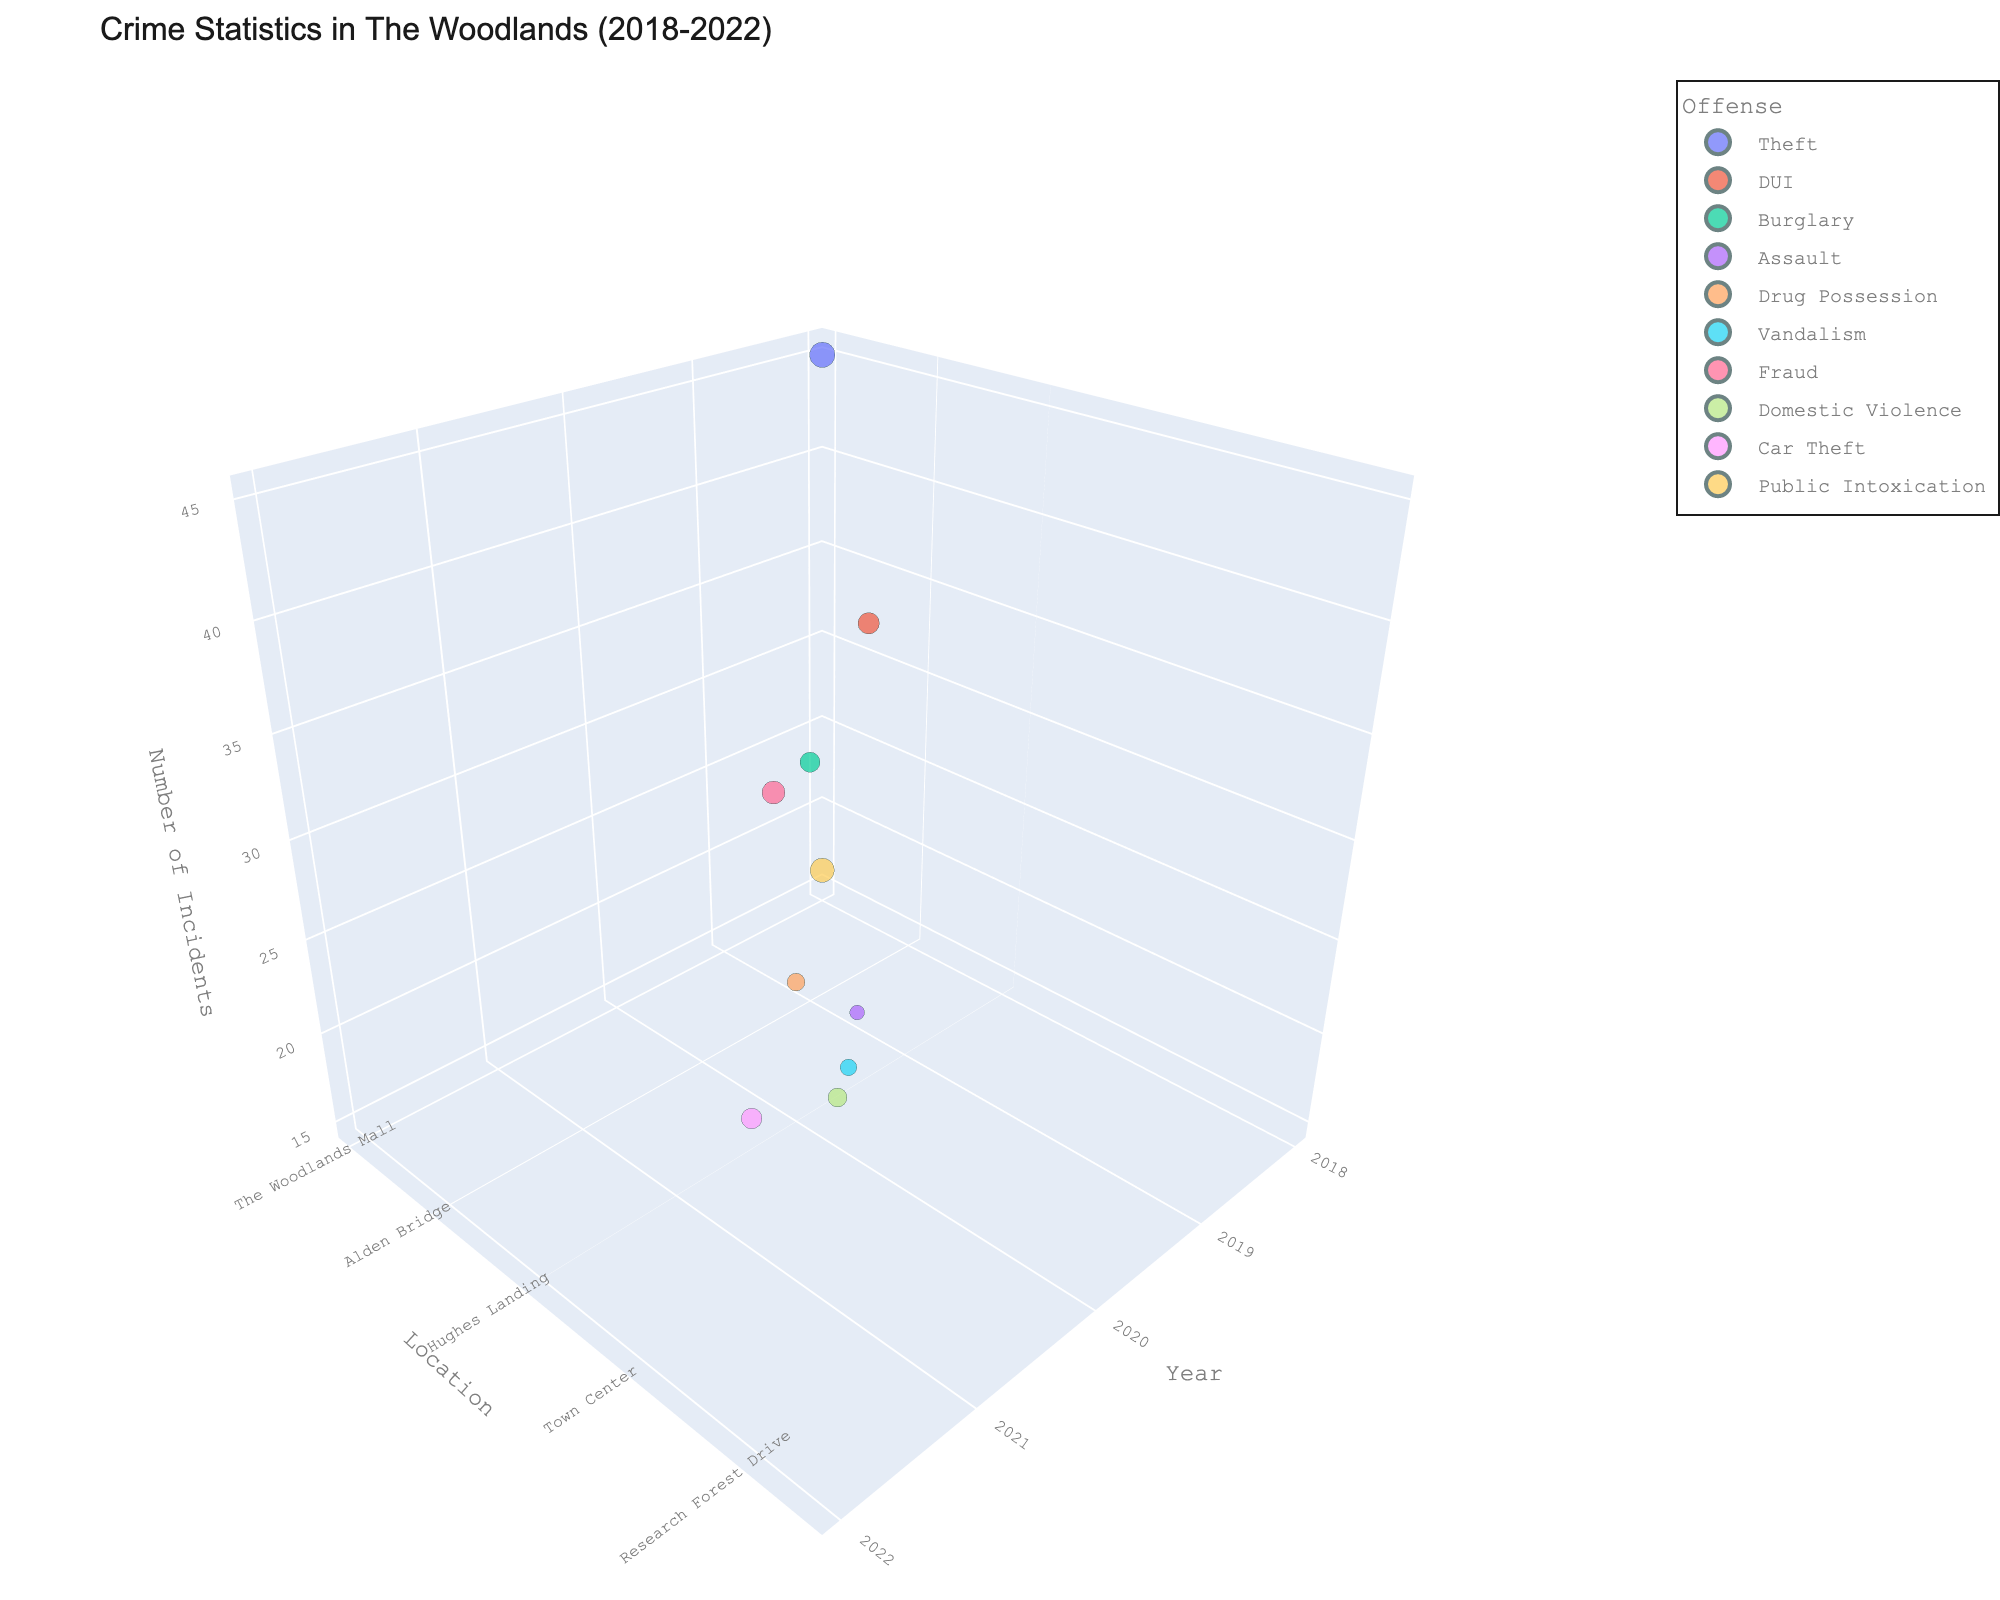What is the title of the 3D scatter plot? The title of the 3D scatter plot is typically displayed at the top of the figure.
Answer: Crime Statistics in The Woodlands (2018-2022) Which location had the highest frequency of car thefts, and what was that frequency? Locate the data points for car thefts using the color assigned to it. The highest frequency data point for car thefts is found on the z-axis.
Answer: Research Forest Drive, 30 How did the frequency of thefts at The Woodlands Mall change over the years? Check the data points labeled as theft and check the position on the x-axis (year) and z-axis (frequency). There is only one data point in the provided years.
Answer: There’s data only for 2018 with a frequency of 45 Which offense has the highest number of incidents in 2022? Filter for the data points corresponding to the year 2022 and compare the z-axis values to identify the highest frequency.
Answer: Public Intoxication Compare the frequency of burglaries in Alden Bridge and assaults in Market Street. Identify the data points for burglary and assaults, then compare their z-axis (frequency) values.
Answer: Burglary (28), Assault (15) What is the median frequency of all offenses in 2020? List the frequencies for all offenses in 2020 and calculate the median. Frequencies listed are 22 for Drug Possession and 19 for Vandalism.
Answer: 20.5 What trend do you observe in the number of incidents of public intoxication over the years? Public Intoxication only has data for 2022, so the trend can't be assessed from multiple years.
Answer: Data only available for 2022 Which offense in The Woodlands saw the largest increase in frequency from 2019 to 2020? Compare the frequency of each offense between the years 2019 and 2020 and identify the largest increase.
Answer: Drug Possession (Increased by 22) Which years had the highest reported incidents of fraud, and what were those frequencies? Identify the data points for fraud and check their corresponding years and z-axis values.
Answer: 2021, 37 How many different locations are recorded in the 3D scatter plot? Count the unique entries on the y-axis (Location) labels.
Answer: 10 